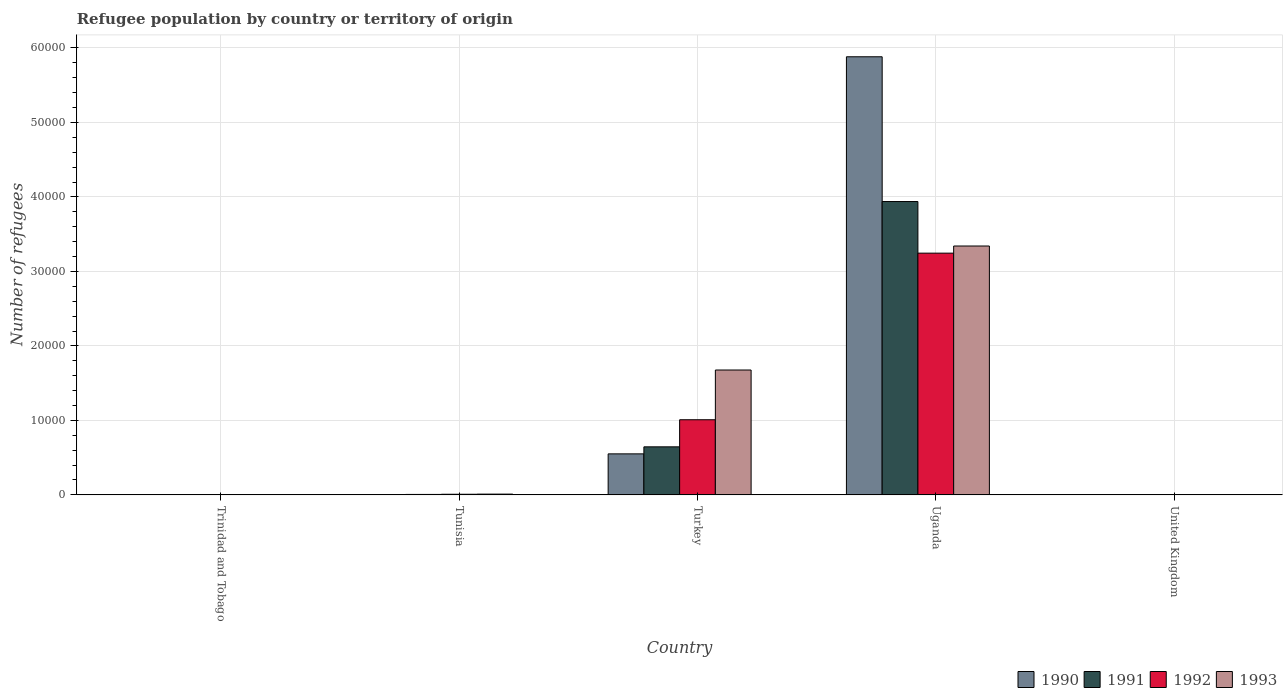How many groups of bars are there?
Keep it short and to the point. 5. Are the number of bars on each tick of the X-axis equal?
Ensure brevity in your answer.  Yes. What is the label of the 2nd group of bars from the left?
Give a very brief answer. Tunisia. In how many cases, is the number of bars for a given country not equal to the number of legend labels?
Your response must be concise. 0. What is the number of refugees in 1990 in Uganda?
Your answer should be very brief. 5.88e+04. Across all countries, what is the maximum number of refugees in 1992?
Your answer should be compact. 3.25e+04. Across all countries, what is the minimum number of refugees in 1991?
Ensure brevity in your answer.  1. In which country was the number of refugees in 1993 maximum?
Offer a very short reply. Uganda. In which country was the number of refugees in 1991 minimum?
Your answer should be very brief. Trinidad and Tobago. What is the total number of refugees in 1990 in the graph?
Make the answer very short. 6.44e+04. What is the difference between the number of refugees in 1992 in Turkey and that in United Kingdom?
Make the answer very short. 1.01e+04. What is the difference between the number of refugees in 1992 in United Kingdom and the number of refugees in 1990 in Trinidad and Tobago?
Your answer should be compact. 0. What is the average number of refugees in 1993 per country?
Offer a terse response. 1.01e+04. What is the difference between the number of refugees of/in 1990 and number of refugees of/in 1992 in Tunisia?
Provide a short and direct response. -44. In how many countries, is the number of refugees in 1992 greater than 18000?
Keep it short and to the point. 1. What is the ratio of the number of refugees in 1991 in Turkey to that in Uganda?
Keep it short and to the point. 0.16. Is the number of refugees in 1990 in Trinidad and Tobago less than that in United Kingdom?
Offer a terse response. No. What is the difference between the highest and the second highest number of refugees in 1990?
Provide a succinct answer. 5466. What is the difference between the highest and the lowest number of refugees in 1993?
Ensure brevity in your answer.  3.34e+04. In how many countries, is the number of refugees in 1992 greater than the average number of refugees in 1992 taken over all countries?
Provide a short and direct response. 2. Is it the case that in every country, the sum of the number of refugees in 1992 and number of refugees in 1991 is greater than the number of refugees in 1993?
Ensure brevity in your answer.  No. How many bars are there?
Give a very brief answer. 20. Are all the bars in the graph horizontal?
Your answer should be very brief. No. How many countries are there in the graph?
Offer a terse response. 5. What is the difference between two consecutive major ticks on the Y-axis?
Provide a short and direct response. 10000. Are the values on the major ticks of Y-axis written in scientific E-notation?
Ensure brevity in your answer.  No. Does the graph contain grids?
Make the answer very short. Yes. How are the legend labels stacked?
Make the answer very short. Horizontal. What is the title of the graph?
Your answer should be very brief. Refugee population by country or territory of origin. Does "2009" appear as one of the legend labels in the graph?
Keep it short and to the point. No. What is the label or title of the X-axis?
Keep it short and to the point. Country. What is the label or title of the Y-axis?
Provide a short and direct response. Number of refugees. What is the Number of refugees of 1990 in Trinidad and Tobago?
Make the answer very short. 1. What is the Number of refugees of 1992 in Trinidad and Tobago?
Your answer should be compact. 1. What is the Number of refugees of 1993 in Trinidad and Tobago?
Keep it short and to the point. 1. What is the Number of refugees of 1991 in Tunisia?
Provide a succinct answer. 63. What is the Number of refugees in 1992 in Tunisia?
Your answer should be compact. 86. What is the Number of refugees in 1993 in Tunisia?
Provide a short and direct response. 104. What is the Number of refugees of 1990 in Turkey?
Keep it short and to the point. 5508. What is the Number of refugees of 1991 in Turkey?
Provide a short and direct response. 6452. What is the Number of refugees of 1992 in Turkey?
Provide a succinct answer. 1.01e+04. What is the Number of refugees in 1993 in Turkey?
Ensure brevity in your answer.  1.68e+04. What is the Number of refugees in 1990 in Uganda?
Offer a terse response. 5.88e+04. What is the Number of refugees in 1991 in Uganda?
Provide a short and direct response. 3.94e+04. What is the Number of refugees in 1992 in Uganda?
Provide a succinct answer. 3.25e+04. What is the Number of refugees in 1993 in Uganda?
Offer a terse response. 3.34e+04. What is the Number of refugees in 1991 in United Kingdom?
Provide a short and direct response. 1. What is the Number of refugees in 1992 in United Kingdom?
Your response must be concise. 1. Across all countries, what is the maximum Number of refugees of 1990?
Your answer should be very brief. 5.88e+04. Across all countries, what is the maximum Number of refugees in 1991?
Provide a succinct answer. 3.94e+04. Across all countries, what is the maximum Number of refugees of 1992?
Your answer should be very brief. 3.25e+04. Across all countries, what is the maximum Number of refugees of 1993?
Keep it short and to the point. 3.34e+04. Across all countries, what is the minimum Number of refugees of 1991?
Make the answer very short. 1. Across all countries, what is the minimum Number of refugees in 1993?
Keep it short and to the point. 1. What is the total Number of refugees in 1990 in the graph?
Make the answer very short. 6.44e+04. What is the total Number of refugees of 1991 in the graph?
Offer a terse response. 4.59e+04. What is the total Number of refugees in 1992 in the graph?
Keep it short and to the point. 4.26e+04. What is the total Number of refugees of 1993 in the graph?
Your response must be concise. 5.03e+04. What is the difference between the Number of refugees in 1990 in Trinidad and Tobago and that in Tunisia?
Make the answer very short. -41. What is the difference between the Number of refugees of 1991 in Trinidad and Tobago and that in Tunisia?
Make the answer very short. -62. What is the difference between the Number of refugees of 1992 in Trinidad and Tobago and that in Tunisia?
Offer a very short reply. -85. What is the difference between the Number of refugees in 1993 in Trinidad and Tobago and that in Tunisia?
Your response must be concise. -103. What is the difference between the Number of refugees in 1990 in Trinidad and Tobago and that in Turkey?
Offer a very short reply. -5507. What is the difference between the Number of refugees of 1991 in Trinidad and Tobago and that in Turkey?
Your answer should be compact. -6451. What is the difference between the Number of refugees of 1992 in Trinidad and Tobago and that in Turkey?
Your response must be concise. -1.01e+04. What is the difference between the Number of refugees in 1993 in Trinidad and Tobago and that in Turkey?
Keep it short and to the point. -1.68e+04. What is the difference between the Number of refugees in 1990 in Trinidad and Tobago and that in Uganda?
Make the answer very short. -5.88e+04. What is the difference between the Number of refugees in 1991 in Trinidad and Tobago and that in Uganda?
Make the answer very short. -3.94e+04. What is the difference between the Number of refugees in 1992 in Trinidad and Tobago and that in Uganda?
Your answer should be very brief. -3.25e+04. What is the difference between the Number of refugees of 1993 in Trinidad and Tobago and that in Uganda?
Offer a terse response. -3.34e+04. What is the difference between the Number of refugees in 1990 in Trinidad and Tobago and that in United Kingdom?
Your answer should be very brief. 0. What is the difference between the Number of refugees in 1991 in Trinidad and Tobago and that in United Kingdom?
Provide a short and direct response. 0. What is the difference between the Number of refugees of 1992 in Trinidad and Tobago and that in United Kingdom?
Ensure brevity in your answer.  0. What is the difference between the Number of refugees in 1990 in Tunisia and that in Turkey?
Provide a succinct answer. -5466. What is the difference between the Number of refugees of 1991 in Tunisia and that in Turkey?
Give a very brief answer. -6389. What is the difference between the Number of refugees of 1992 in Tunisia and that in Turkey?
Your response must be concise. -1.00e+04. What is the difference between the Number of refugees of 1993 in Tunisia and that in Turkey?
Your response must be concise. -1.67e+04. What is the difference between the Number of refugees in 1990 in Tunisia and that in Uganda?
Provide a short and direct response. -5.88e+04. What is the difference between the Number of refugees of 1991 in Tunisia and that in Uganda?
Give a very brief answer. -3.93e+04. What is the difference between the Number of refugees of 1992 in Tunisia and that in Uganda?
Your answer should be compact. -3.24e+04. What is the difference between the Number of refugees in 1993 in Tunisia and that in Uganda?
Your response must be concise. -3.33e+04. What is the difference between the Number of refugees of 1990 in Tunisia and that in United Kingdom?
Offer a very short reply. 41. What is the difference between the Number of refugees of 1991 in Tunisia and that in United Kingdom?
Give a very brief answer. 62. What is the difference between the Number of refugees of 1992 in Tunisia and that in United Kingdom?
Your answer should be compact. 85. What is the difference between the Number of refugees of 1993 in Tunisia and that in United Kingdom?
Provide a short and direct response. 102. What is the difference between the Number of refugees of 1990 in Turkey and that in Uganda?
Offer a very short reply. -5.33e+04. What is the difference between the Number of refugees of 1991 in Turkey and that in Uganda?
Offer a very short reply. -3.29e+04. What is the difference between the Number of refugees in 1992 in Turkey and that in Uganda?
Provide a short and direct response. -2.24e+04. What is the difference between the Number of refugees in 1993 in Turkey and that in Uganda?
Your answer should be very brief. -1.66e+04. What is the difference between the Number of refugees of 1990 in Turkey and that in United Kingdom?
Ensure brevity in your answer.  5507. What is the difference between the Number of refugees of 1991 in Turkey and that in United Kingdom?
Make the answer very short. 6451. What is the difference between the Number of refugees in 1992 in Turkey and that in United Kingdom?
Offer a terse response. 1.01e+04. What is the difference between the Number of refugees of 1993 in Turkey and that in United Kingdom?
Provide a short and direct response. 1.68e+04. What is the difference between the Number of refugees in 1990 in Uganda and that in United Kingdom?
Provide a succinct answer. 5.88e+04. What is the difference between the Number of refugees in 1991 in Uganda and that in United Kingdom?
Offer a very short reply. 3.94e+04. What is the difference between the Number of refugees of 1992 in Uganda and that in United Kingdom?
Provide a succinct answer. 3.25e+04. What is the difference between the Number of refugees of 1993 in Uganda and that in United Kingdom?
Make the answer very short. 3.34e+04. What is the difference between the Number of refugees of 1990 in Trinidad and Tobago and the Number of refugees of 1991 in Tunisia?
Give a very brief answer. -62. What is the difference between the Number of refugees of 1990 in Trinidad and Tobago and the Number of refugees of 1992 in Tunisia?
Make the answer very short. -85. What is the difference between the Number of refugees of 1990 in Trinidad and Tobago and the Number of refugees of 1993 in Tunisia?
Your response must be concise. -103. What is the difference between the Number of refugees in 1991 in Trinidad and Tobago and the Number of refugees in 1992 in Tunisia?
Keep it short and to the point. -85. What is the difference between the Number of refugees of 1991 in Trinidad and Tobago and the Number of refugees of 1993 in Tunisia?
Your response must be concise. -103. What is the difference between the Number of refugees in 1992 in Trinidad and Tobago and the Number of refugees in 1993 in Tunisia?
Keep it short and to the point. -103. What is the difference between the Number of refugees of 1990 in Trinidad and Tobago and the Number of refugees of 1991 in Turkey?
Give a very brief answer. -6451. What is the difference between the Number of refugees in 1990 in Trinidad and Tobago and the Number of refugees in 1992 in Turkey?
Provide a succinct answer. -1.01e+04. What is the difference between the Number of refugees of 1990 in Trinidad and Tobago and the Number of refugees of 1993 in Turkey?
Your response must be concise. -1.68e+04. What is the difference between the Number of refugees in 1991 in Trinidad and Tobago and the Number of refugees in 1992 in Turkey?
Give a very brief answer. -1.01e+04. What is the difference between the Number of refugees in 1991 in Trinidad and Tobago and the Number of refugees in 1993 in Turkey?
Offer a terse response. -1.68e+04. What is the difference between the Number of refugees of 1992 in Trinidad and Tobago and the Number of refugees of 1993 in Turkey?
Provide a short and direct response. -1.68e+04. What is the difference between the Number of refugees of 1990 in Trinidad and Tobago and the Number of refugees of 1991 in Uganda?
Offer a terse response. -3.94e+04. What is the difference between the Number of refugees of 1990 in Trinidad and Tobago and the Number of refugees of 1992 in Uganda?
Make the answer very short. -3.25e+04. What is the difference between the Number of refugees in 1990 in Trinidad and Tobago and the Number of refugees in 1993 in Uganda?
Your response must be concise. -3.34e+04. What is the difference between the Number of refugees of 1991 in Trinidad and Tobago and the Number of refugees of 1992 in Uganda?
Ensure brevity in your answer.  -3.25e+04. What is the difference between the Number of refugees of 1991 in Trinidad and Tobago and the Number of refugees of 1993 in Uganda?
Make the answer very short. -3.34e+04. What is the difference between the Number of refugees in 1992 in Trinidad and Tobago and the Number of refugees in 1993 in Uganda?
Your answer should be compact. -3.34e+04. What is the difference between the Number of refugees of 1990 in Trinidad and Tobago and the Number of refugees of 1991 in United Kingdom?
Offer a terse response. 0. What is the difference between the Number of refugees in 1990 in Trinidad and Tobago and the Number of refugees in 1993 in United Kingdom?
Make the answer very short. -1. What is the difference between the Number of refugees of 1991 in Trinidad and Tobago and the Number of refugees of 1993 in United Kingdom?
Provide a short and direct response. -1. What is the difference between the Number of refugees in 1992 in Trinidad and Tobago and the Number of refugees in 1993 in United Kingdom?
Offer a very short reply. -1. What is the difference between the Number of refugees in 1990 in Tunisia and the Number of refugees in 1991 in Turkey?
Keep it short and to the point. -6410. What is the difference between the Number of refugees of 1990 in Tunisia and the Number of refugees of 1992 in Turkey?
Provide a short and direct response. -1.00e+04. What is the difference between the Number of refugees of 1990 in Tunisia and the Number of refugees of 1993 in Turkey?
Ensure brevity in your answer.  -1.67e+04. What is the difference between the Number of refugees in 1991 in Tunisia and the Number of refugees in 1992 in Turkey?
Your response must be concise. -1.00e+04. What is the difference between the Number of refugees in 1991 in Tunisia and the Number of refugees in 1993 in Turkey?
Your answer should be very brief. -1.67e+04. What is the difference between the Number of refugees of 1992 in Tunisia and the Number of refugees of 1993 in Turkey?
Give a very brief answer. -1.67e+04. What is the difference between the Number of refugees in 1990 in Tunisia and the Number of refugees in 1991 in Uganda?
Your answer should be compact. -3.93e+04. What is the difference between the Number of refugees of 1990 in Tunisia and the Number of refugees of 1992 in Uganda?
Provide a short and direct response. -3.24e+04. What is the difference between the Number of refugees of 1990 in Tunisia and the Number of refugees of 1993 in Uganda?
Provide a succinct answer. -3.34e+04. What is the difference between the Number of refugees of 1991 in Tunisia and the Number of refugees of 1992 in Uganda?
Offer a very short reply. -3.24e+04. What is the difference between the Number of refugees in 1991 in Tunisia and the Number of refugees in 1993 in Uganda?
Ensure brevity in your answer.  -3.34e+04. What is the difference between the Number of refugees of 1992 in Tunisia and the Number of refugees of 1993 in Uganda?
Offer a terse response. -3.33e+04. What is the difference between the Number of refugees of 1990 in Tunisia and the Number of refugees of 1992 in United Kingdom?
Your answer should be compact. 41. What is the difference between the Number of refugees of 1990 in Tunisia and the Number of refugees of 1993 in United Kingdom?
Provide a short and direct response. 40. What is the difference between the Number of refugees of 1990 in Turkey and the Number of refugees of 1991 in Uganda?
Your answer should be compact. -3.39e+04. What is the difference between the Number of refugees in 1990 in Turkey and the Number of refugees in 1992 in Uganda?
Offer a very short reply. -2.69e+04. What is the difference between the Number of refugees in 1990 in Turkey and the Number of refugees in 1993 in Uganda?
Give a very brief answer. -2.79e+04. What is the difference between the Number of refugees in 1991 in Turkey and the Number of refugees in 1992 in Uganda?
Keep it short and to the point. -2.60e+04. What is the difference between the Number of refugees in 1991 in Turkey and the Number of refugees in 1993 in Uganda?
Provide a succinct answer. -2.70e+04. What is the difference between the Number of refugees of 1992 in Turkey and the Number of refugees of 1993 in Uganda?
Give a very brief answer. -2.33e+04. What is the difference between the Number of refugees of 1990 in Turkey and the Number of refugees of 1991 in United Kingdom?
Offer a very short reply. 5507. What is the difference between the Number of refugees in 1990 in Turkey and the Number of refugees in 1992 in United Kingdom?
Offer a very short reply. 5507. What is the difference between the Number of refugees of 1990 in Turkey and the Number of refugees of 1993 in United Kingdom?
Offer a very short reply. 5506. What is the difference between the Number of refugees of 1991 in Turkey and the Number of refugees of 1992 in United Kingdom?
Ensure brevity in your answer.  6451. What is the difference between the Number of refugees of 1991 in Turkey and the Number of refugees of 1993 in United Kingdom?
Your answer should be very brief. 6450. What is the difference between the Number of refugees of 1992 in Turkey and the Number of refugees of 1993 in United Kingdom?
Your answer should be compact. 1.01e+04. What is the difference between the Number of refugees of 1990 in Uganda and the Number of refugees of 1991 in United Kingdom?
Keep it short and to the point. 5.88e+04. What is the difference between the Number of refugees in 1990 in Uganda and the Number of refugees in 1992 in United Kingdom?
Ensure brevity in your answer.  5.88e+04. What is the difference between the Number of refugees in 1990 in Uganda and the Number of refugees in 1993 in United Kingdom?
Make the answer very short. 5.88e+04. What is the difference between the Number of refugees of 1991 in Uganda and the Number of refugees of 1992 in United Kingdom?
Provide a succinct answer. 3.94e+04. What is the difference between the Number of refugees of 1991 in Uganda and the Number of refugees of 1993 in United Kingdom?
Ensure brevity in your answer.  3.94e+04. What is the difference between the Number of refugees of 1992 in Uganda and the Number of refugees of 1993 in United Kingdom?
Provide a short and direct response. 3.25e+04. What is the average Number of refugees of 1990 per country?
Your answer should be very brief. 1.29e+04. What is the average Number of refugees in 1991 per country?
Offer a terse response. 9180.6. What is the average Number of refugees in 1992 per country?
Your answer should be very brief. 8526.6. What is the average Number of refugees in 1993 per country?
Provide a succinct answer. 1.01e+04. What is the difference between the Number of refugees of 1990 and Number of refugees of 1993 in Trinidad and Tobago?
Keep it short and to the point. 0. What is the difference between the Number of refugees of 1991 and Number of refugees of 1993 in Trinidad and Tobago?
Your answer should be compact. 0. What is the difference between the Number of refugees in 1990 and Number of refugees in 1992 in Tunisia?
Your response must be concise. -44. What is the difference between the Number of refugees in 1990 and Number of refugees in 1993 in Tunisia?
Offer a very short reply. -62. What is the difference between the Number of refugees of 1991 and Number of refugees of 1993 in Tunisia?
Provide a succinct answer. -41. What is the difference between the Number of refugees in 1990 and Number of refugees in 1991 in Turkey?
Your response must be concise. -944. What is the difference between the Number of refugees in 1990 and Number of refugees in 1992 in Turkey?
Provide a short and direct response. -4581. What is the difference between the Number of refugees in 1990 and Number of refugees in 1993 in Turkey?
Keep it short and to the point. -1.13e+04. What is the difference between the Number of refugees of 1991 and Number of refugees of 1992 in Turkey?
Provide a succinct answer. -3637. What is the difference between the Number of refugees of 1991 and Number of refugees of 1993 in Turkey?
Provide a succinct answer. -1.03e+04. What is the difference between the Number of refugees of 1992 and Number of refugees of 1993 in Turkey?
Your response must be concise. -6679. What is the difference between the Number of refugees in 1990 and Number of refugees in 1991 in Uganda?
Provide a short and direct response. 1.94e+04. What is the difference between the Number of refugees of 1990 and Number of refugees of 1992 in Uganda?
Provide a short and direct response. 2.64e+04. What is the difference between the Number of refugees of 1990 and Number of refugees of 1993 in Uganda?
Offer a very short reply. 2.54e+04. What is the difference between the Number of refugees of 1991 and Number of refugees of 1992 in Uganda?
Your answer should be compact. 6930. What is the difference between the Number of refugees in 1991 and Number of refugees in 1993 in Uganda?
Ensure brevity in your answer.  5971. What is the difference between the Number of refugees in 1992 and Number of refugees in 1993 in Uganda?
Your response must be concise. -959. What is the difference between the Number of refugees in 1990 and Number of refugees in 1991 in United Kingdom?
Keep it short and to the point. 0. What is the difference between the Number of refugees in 1990 and Number of refugees in 1992 in United Kingdom?
Keep it short and to the point. 0. What is the difference between the Number of refugees of 1990 and Number of refugees of 1993 in United Kingdom?
Provide a short and direct response. -1. What is the difference between the Number of refugees in 1991 and Number of refugees in 1993 in United Kingdom?
Your response must be concise. -1. What is the ratio of the Number of refugees of 1990 in Trinidad and Tobago to that in Tunisia?
Your response must be concise. 0.02. What is the ratio of the Number of refugees of 1991 in Trinidad and Tobago to that in Tunisia?
Offer a very short reply. 0.02. What is the ratio of the Number of refugees of 1992 in Trinidad and Tobago to that in Tunisia?
Ensure brevity in your answer.  0.01. What is the ratio of the Number of refugees of 1993 in Trinidad and Tobago to that in Tunisia?
Offer a terse response. 0.01. What is the ratio of the Number of refugees of 1991 in Trinidad and Tobago to that in Turkey?
Keep it short and to the point. 0. What is the ratio of the Number of refugees in 1990 in Trinidad and Tobago to that in Uganda?
Keep it short and to the point. 0. What is the ratio of the Number of refugees in 1993 in Trinidad and Tobago to that in Uganda?
Give a very brief answer. 0. What is the ratio of the Number of refugees of 1990 in Trinidad and Tobago to that in United Kingdom?
Your answer should be compact. 1. What is the ratio of the Number of refugees in 1991 in Trinidad and Tobago to that in United Kingdom?
Make the answer very short. 1. What is the ratio of the Number of refugees in 1990 in Tunisia to that in Turkey?
Offer a terse response. 0.01. What is the ratio of the Number of refugees in 1991 in Tunisia to that in Turkey?
Ensure brevity in your answer.  0.01. What is the ratio of the Number of refugees in 1992 in Tunisia to that in Turkey?
Offer a terse response. 0.01. What is the ratio of the Number of refugees of 1993 in Tunisia to that in Turkey?
Offer a very short reply. 0.01. What is the ratio of the Number of refugees in 1990 in Tunisia to that in Uganda?
Your answer should be very brief. 0. What is the ratio of the Number of refugees in 1991 in Tunisia to that in Uganda?
Your response must be concise. 0. What is the ratio of the Number of refugees in 1992 in Tunisia to that in Uganda?
Ensure brevity in your answer.  0. What is the ratio of the Number of refugees in 1993 in Tunisia to that in Uganda?
Your answer should be very brief. 0. What is the ratio of the Number of refugees of 1992 in Tunisia to that in United Kingdom?
Provide a short and direct response. 86. What is the ratio of the Number of refugees of 1993 in Tunisia to that in United Kingdom?
Provide a succinct answer. 52. What is the ratio of the Number of refugees in 1990 in Turkey to that in Uganda?
Offer a terse response. 0.09. What is the ratio of the Number of refugees in 1991 in Turkey to that in Uganda?
Ensure brevity in your answer.  0.16. What is the ratio of the Number of refugees of 1992 in Turkey to that in Uganda?
Your answer should be compact. 0.31. What is the ratio of the Number of refugees in 1993 in Turkey to that in Uganda?
Keep it short and to the point. 0.5. What is the ratio of the Number of refugees of 1990 in Turkey to that in United Kingdom?
Keep it short and to the point. 5508. What is the ratio of the Number of refugees of 1991 in Turkey to that in United Kingdom?
Provide a succinct answer. 6452. What is the ratio of the Number of refugees of 1992 in Turkey to that in United Kingdom?
Offer a very short reply. 1.01e+04. What is the ratio of the Number of refugees in 1993 in Turkey to that in United Kingdom?
Make the answer very short. 8384. What is the ratio of the Number of refugees in 1990 in Uganda to that in United Kingdom?
Your answer should be compact. 5.88e+04. What is the ratio of the Number of refugees of 1991 in Uganda to that in United Kingdom?
Provide a succinct answer. 3.94e+04. What is the ratio of the Number of refugees in 1992 in Uganda to that in United Kingdom?
Give a very brief answer. 3.25e+04. What is the ratio of the Number of refugees in 1993 in Uganda to that in United Kingdom?
Offer a terse response. 1.67e+04. What is the difference between the highest and the second highest Number of refugees of 1990?
Your response must be concise. 5.33e+04. What is the difference between the highest and the second highest Number of refugees in 1991?
Offer a terse response. 3.29e+04. What is the difference between the highest and the second highest Number of refugees of 1992?
Provide a succinct answer. 2.24e+04. What is the difference between the highest and the second highest Number of refugees in 1993?
Your answer should be very brief. 1.66e+04. What is the difference between the highest and the lowest Number of refugees of 1990?
Your response must be concise. 5.88e+04. What is the difference between the highest and the lowest Number of refugees of 1991?
Your response must be concise. 3.94e+04. What is the difference between the highest and the lowest Number of refugees of 1992?
Your answer should be compact. 3.25e+04. What is the difference between the highest and the lowest Number of refugees of 1993?
Your answer should be compact. 3.34e+04. 